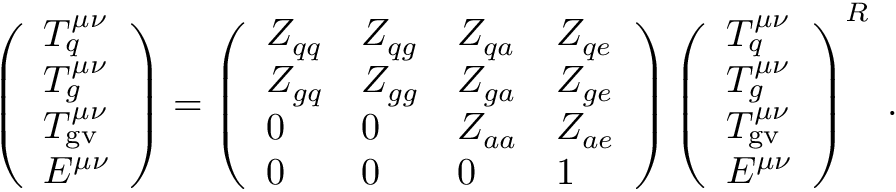<formula> <loc_0><loc_0><loc_500><loc_500>\left ( \begin{array} { l } { { T _ { q } ^ { \mu \nu } } } \\ { { T _ { g } ^ { \mu \nu } } } \\ { { T _ { g v } ^ { \mu \nu } } } \\ { { E ^ { \mu \nu } } } \end{array} \right ) = \left ( \begin{array} { l l l l } { { Z _ { q q } } } & { { Z _ { q g } } } & { { Z _ { q a } } } & { { Z _ { q e } } } \\ { { Z _ { g q } } } & { { Z _ { g g } } } & { { Z _ { g a } } } & { { Z _ { g e } } } \\ { 0 } & { 0 } & { { Z _ { a a } } } & { { Z _ { a e } } } \\ { 0 } & { 0 } & { 0 } & { 1 } \end{array} \right ) \left ( \begin{array} { l } { { T _ { q } ^ { \mu \nu } } } \\ { { T _ { g } ^ { \mu \nu } } } \\ { { T _ { g v } ^ { \mu \nu } } } \\ { { E ^ { \mu \nu } } } \end{array} \right ) ^ { R } \, .</formula> 